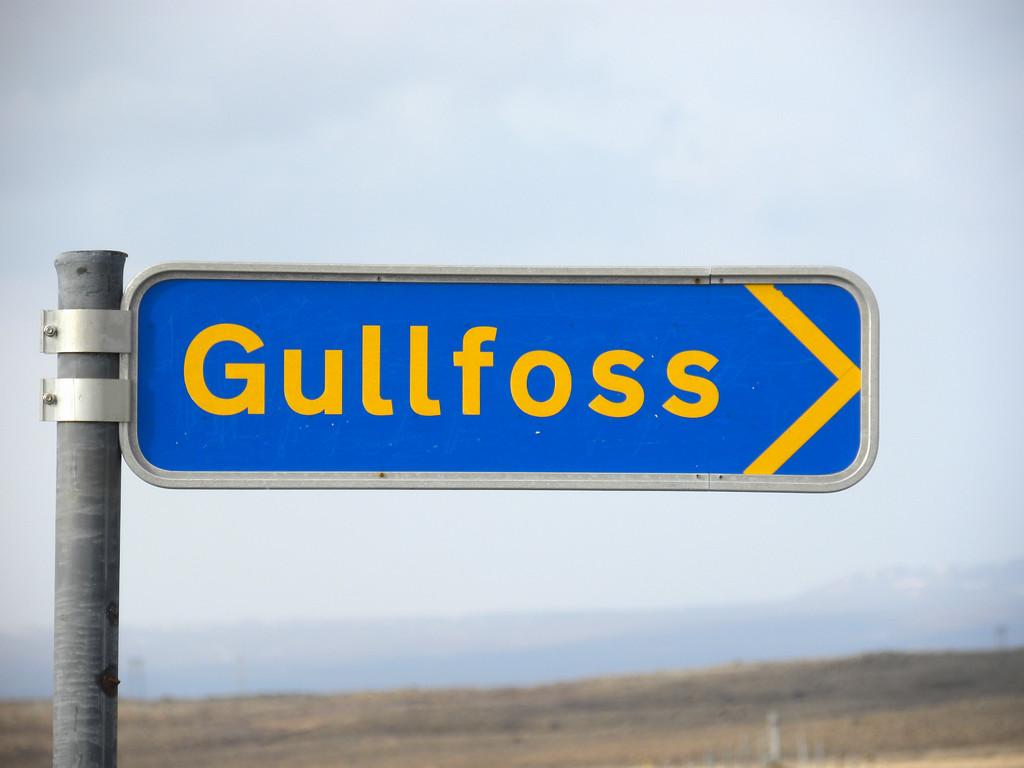What street are we on?
Your response must be concise. Gullfoss. 